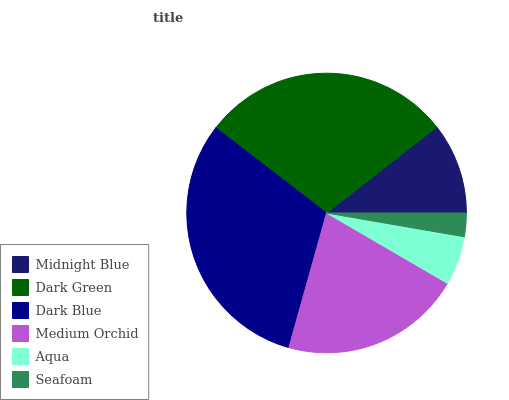Is Seafoam the minimum?
Answer yes or no. Yes. Is Dark Blue the maximum?
Answer yes or no. Yes. Is Dark Green the minimum?
Answer yes or no. No. Is Dark Green the maximum?
Answer yes or no. No. Is Dark Green greater than Midnight Blue?
Answer yes or no. Yes. Is Midnight Blue less than Dark Green?
Answer yes or no. Yes. Is Midnight Blue greater than Dark Green?
Answer yes or no. No. Is Dark Green less than Midnight Blue?
Answer yes or no. No. Is Medium Orchid the high median?
Answer yes or no. Yes. Is Midnight Blue the low median?
Answer yes or no. Yes. Is Aqua the high median?
Answer yes or no. No. Is Aqua the low median?
Answer yes or no. No. 